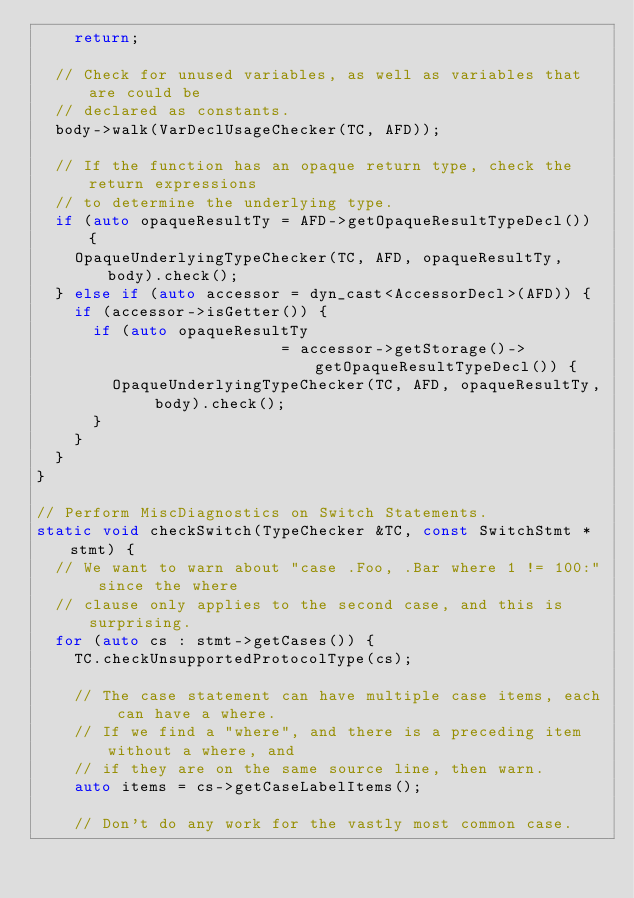Convert code to text. <code><loc_0><loc_0><loc_500><loc_500><_C++_>    return;
  
  // Check for unused variables, as well as variables that are could be
  // declared as constants.
  body->walk(VarDeclUsageChecker(TC, AFD));
  
  // If the function has an opaque return type, check the return expressions
  // to determine the underlying type.
  if (auto opaqueResultTy = AFD->getOpaqueResultTypeDecl()) {
    OpaqueUnderlyingTypeChecker(TC, AFD, opaqueResultTy, body).check();
  } else if (auto accessor = dyn_cast<AccessorDecl>(AFD)) {
    if (accessor->isGetter()) {
      if (auto opaqueResultTy
                          = accessor->getStorage()->getOpaqueResultTypeDecl()) {
        OpaqueUnderlyingTypeChecker(TC, AFD, opaqueResultTy, body).check();
      }
    }
  }
}

// Perform MiscDiagnostics on Switch Statements.
static void checkSwitch(TypeChecker &TC, const SwitchStmt *stmt) {
  // We want to warn about "case .Foo, .Bar where 1 != 100:" since the where
  // clause only applies to the second case, and this is surprising.
  for (auto cs : stmt->getCases()) {
    TC.checkUnsupportedProtocolType(cs);

    // The case statement can have multiple case items, each can have a where.
    // If we find a "where", and there is a preceding item without a where, and
    // if they are on the same source line, then warn.
    auto items = cs->getCaseLabelItems();
    
    // Don't do any work for the vastly most common case.</code> 